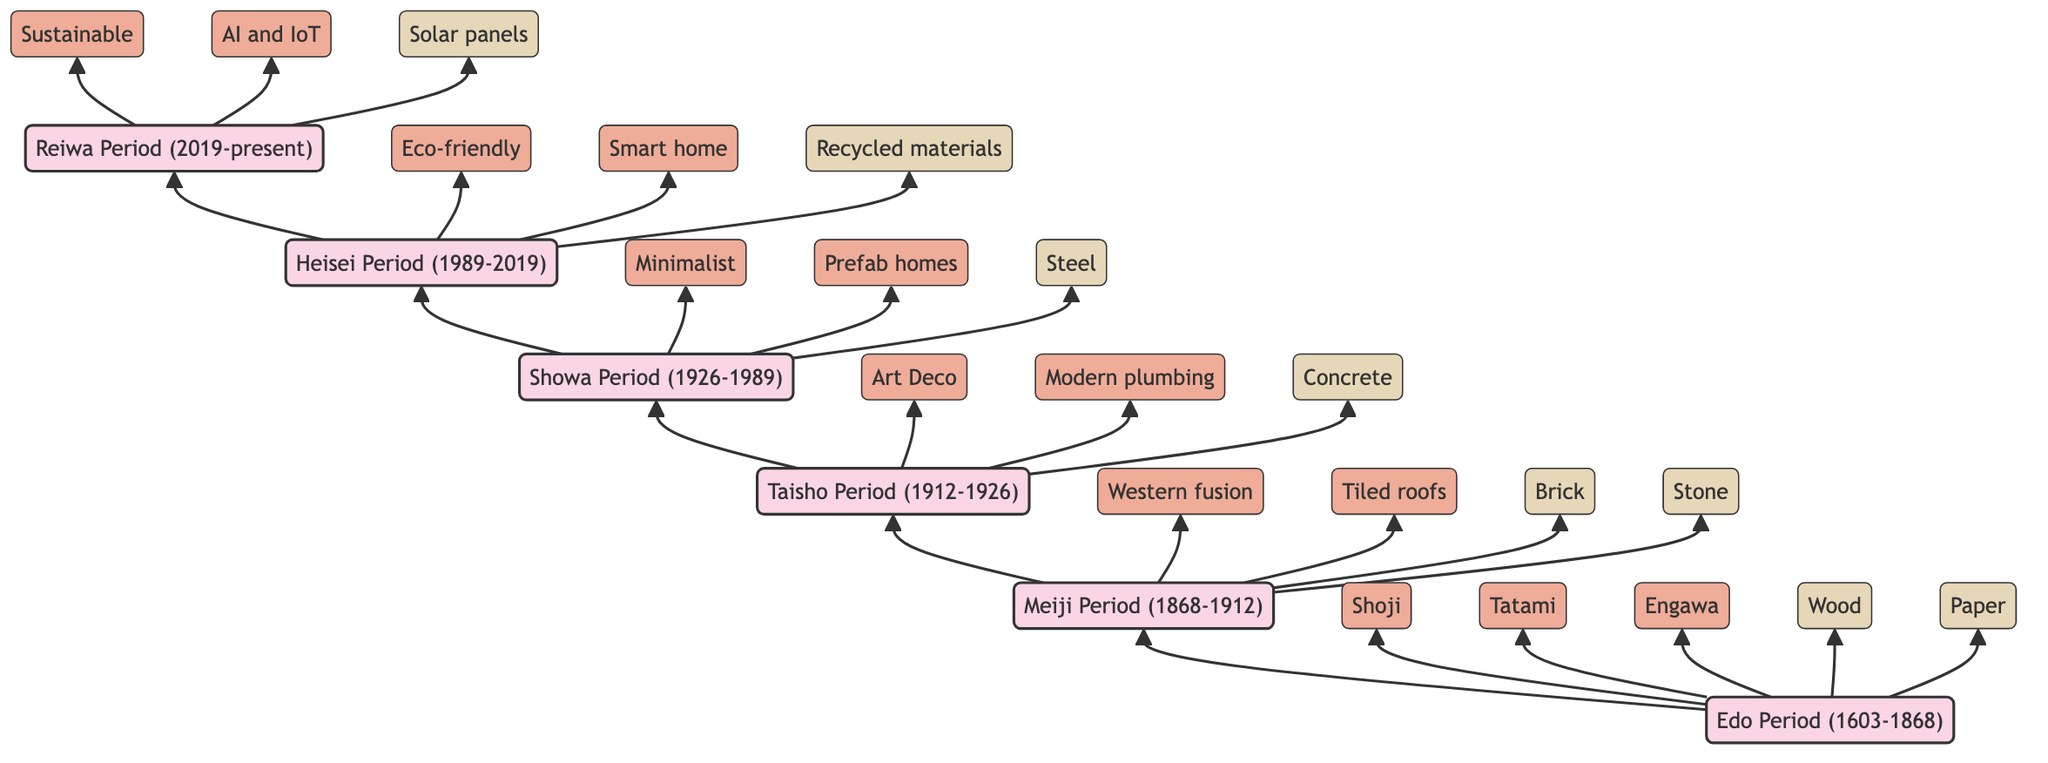What period immediately follows the Edo Period? The diagram indicates a direct flow from the Edo Period to the Meiji Period, showing that Meiji comes next in the evolutionary timeline.
Answer: Meiji Period How many characteristics are listed for the Taisho Period? The diagram provides two characteristics nodes beneath the Taisho Period node, indicating that there are two characteristics specifically associated with this period.
Answer: 2 What is one sustainable feature of homes from the Reiwa Period? The diagram presents the characteristic nodes for the Reiwa Period, where one of the listed features is "Sustainable." This directly addresses the question about sustainable design concepts from this period.
Answer: Sustainable Which period introduced prefab homes? By following the flow from the Showa Period, we can see it is connected to the characteristic "Prefab homes," meaning this period was where this kind of home design was integrated into the architecture.
Answer: Showa Period What materials are associated with the Heisei Period? The diagram connects the Heisei Period to three material nodes: Recycled materials, Wood, Concrete, and Glass, which specify the materials relevant to this period of home architecture.
Answer: Recycled materials, Wood, Concrete, Glass What type of elements were incorporated in homes during the Meiji Period? The diagram's connections show that the Meiji Period introduces the characteristic "Western fusion," indicating a blend of Western styles in architecture of that era.
Answer: Western fusion Which two periods focused on eco-friendly designs? Analyzing the diagram, we can identify that both the Heisei and Reiwa periods have the characteristic "Eco-friendly," indicating a shared focus on sustainable design principles.
Answer: Heisei Period, Reiwa Period What materials are unique to the Edo Period? The diagram specifies that during the Edo Period, the materials used included Wood, Paper, Bamboo, and Straw, detailing what was unique to this architectural phase.
Answer: Wood, Paper, Bamboo, Straw Which period is characterized by minimalism and integration of modern technology? By examining the Showa Period node, we see the characteristic "Minimalist style" and "Integration of modern technology," uniquely identifying this period's architectural focus.
Answer: Showa Period 